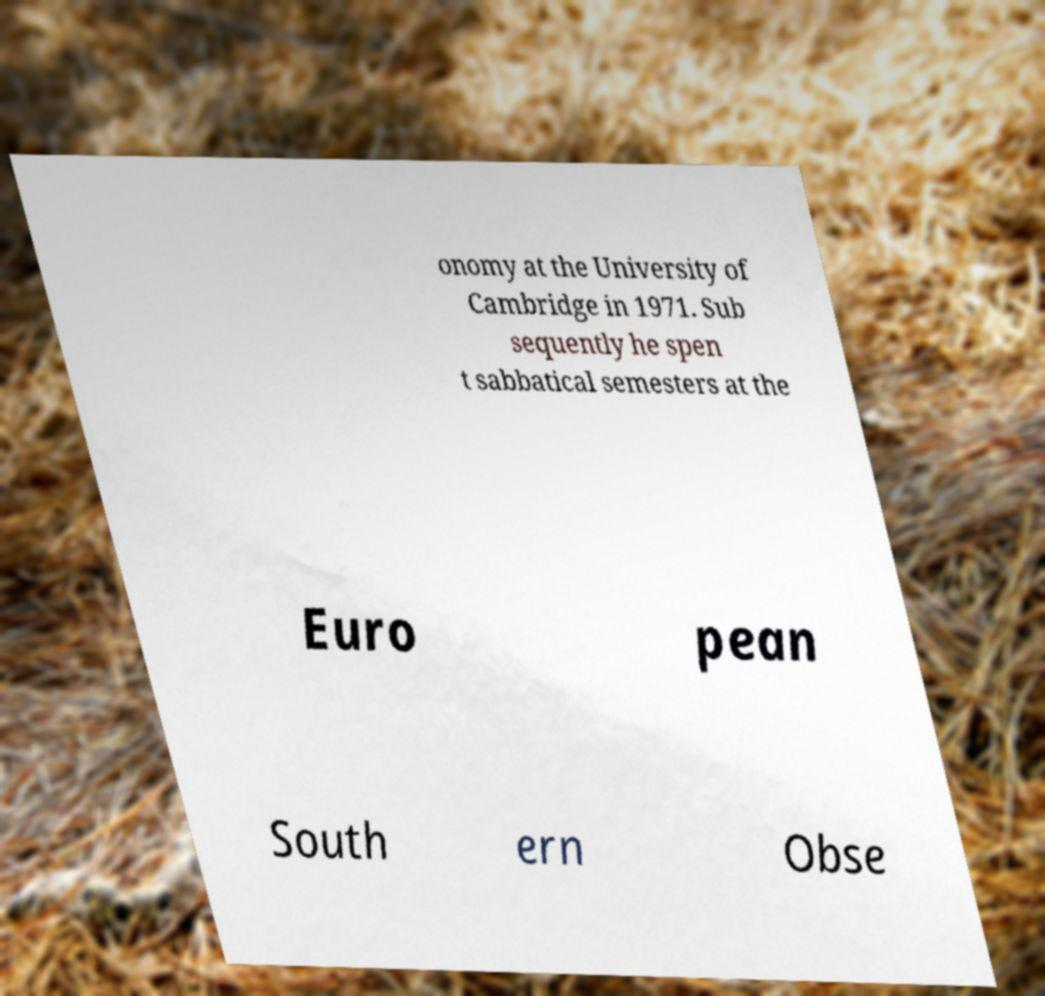For documentation purposes, I need the text within this image transcribed. Could you provide that? onomy at the University of Cambridge in 1971. Sub sequently he spen t sabbatical semesters at the Euro pean South ern Obse 